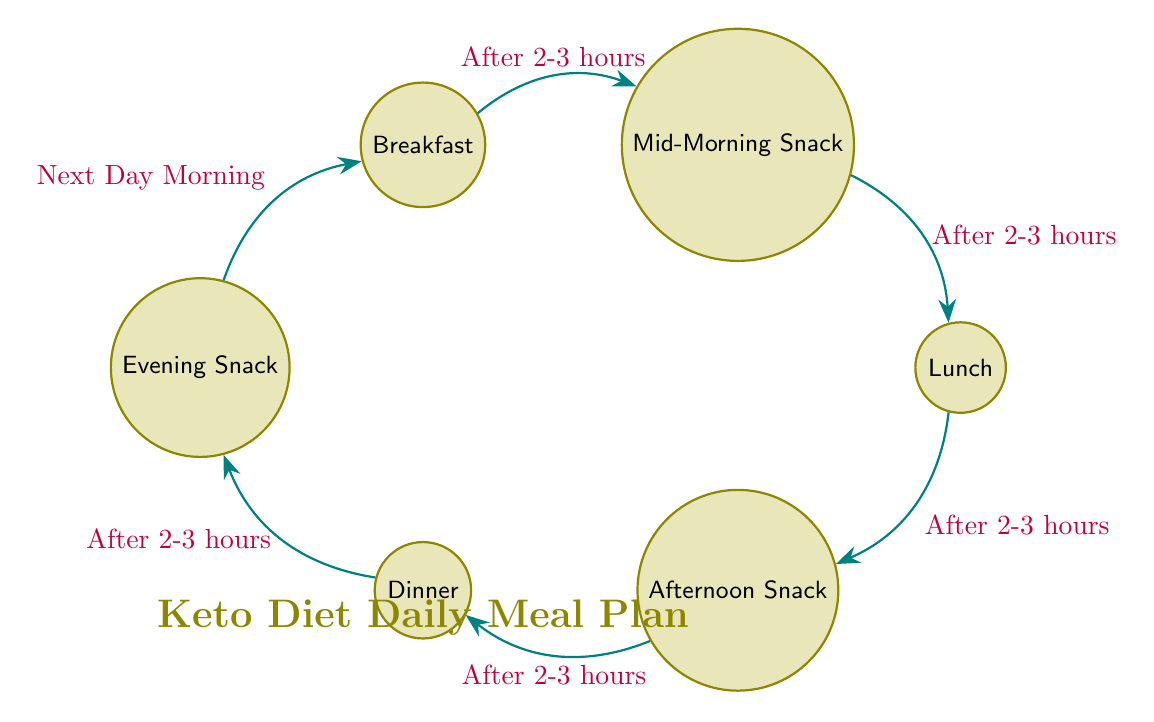What is the first meal in the diagram? The diagram starts with the "Breakfast" state, which is the initial meal in the daily meal plan.
Answer: Breakfast How many states are represented in the diagram? There are six states in the diagram: Breakfast, Mid-Morning Snack, Lunch, Afternoon Snack, Dinner, and Evening Snack, which totals to six.
Answer: 6 What transition follows after consuming lunch? After consuming Lunch, the transition is to the Afternoon Snack state, meaning the next meal is Afternoon Snack.
Answer: Afternoon Snack What is the time condition required to move from Afternoon Snack to Dinner? The transition from Afternoon Snack to Dinner happens after 2-3 hours.
Answer: After 2-3 hours What meal comes after Evening Snack? After Evening Snack, the diagram transitions back to Breakfast, indicating the daily cycle starts over.
Answer: Breakfast Which meal transition occurs after a time interval of "Next Day Morning"? The transition that happens after "Next Day Morning" is from Evening Snack back to Breakfast.
Answer: Breakfast How many transitions are there in total? The number of transitions is five, as there are five connections that guide the flow between the states.
Answer: 5 What meal occurs just before Dinner in the sequence? The meal that occurs just before Dinner is the Afternoon Snack, which transitions to Dinner after 2-3 hours.
Answer: Afternoon Snack Which meal transition does not require a specific time condition? The transition from Evening Snack back to Breakfast is based on the condition of "Next Day Morning," which is not hourly but rather time-based on the next day.
Answer: Next Day Morning 